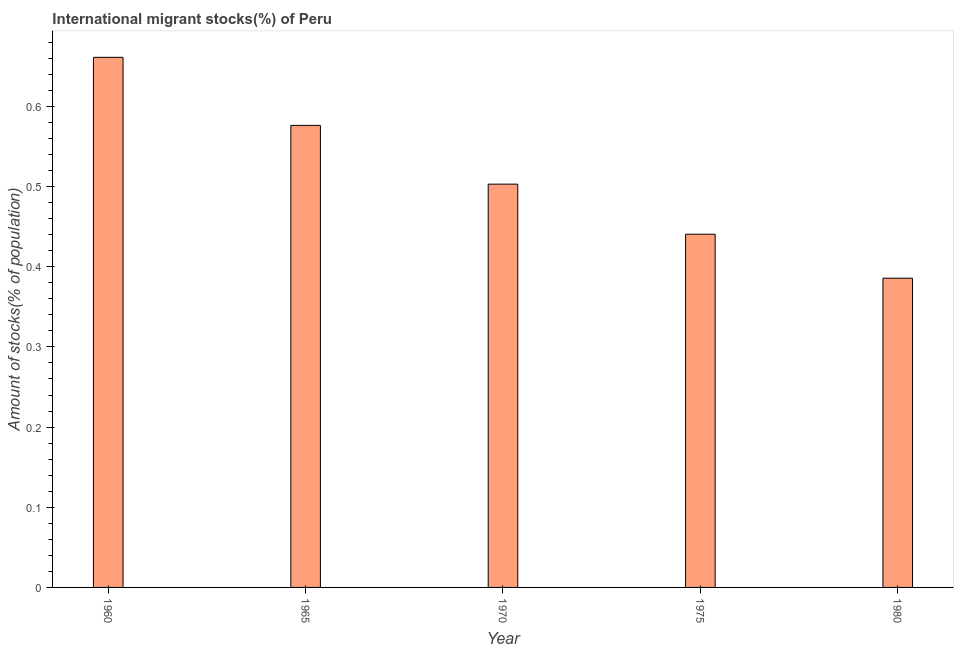Does the graph contain grids?
Your answer should be compact. No. What is the title of the graph?
Provide a short and direct response. International migrant stocks(%) of Peru. What is the label or title of the Y-axis?
Give a very brief answer. Amount of stocks(% of population). What is the number of international migrant stocks in 1965?
Your answer should be compact. 0.58. Across all years, what is the maximum number of international migrant stocks?
Make the answer very short. 0.66. Across all years, what is the minimum number of international migrant stocks?
Provide a short and direct response. 0.39. What is the sum of the number of international migrant stocks?
Your answer should be compact. 2.57. What is the difference between the number of international migrant stocks in 1975 and 1980?
Offer a terse response. 0.06. What is the average number of international migrant stocks per year?
Your answer should be very brief. 0.51. What is the median number of international migrant stocks?
Provide a short and direct response. 0.5. Do a majority of the years between 1965 and 1975 (inclusive) have number of international migrant stocks greater than 0.58 %?
Your answer should be compact. No. What is the ratio of the number of international migrant stocks in 1960 to that in 1970?
Provide a short and direct response. 1.31. What is the difference between the highest and the second highest number of international migrant stocks?
Your answer should be very brief. 0.09. Is the sum of the number of international migrant stocks in 1960 and 1980 greater than the maximum number of international migrant stocks across all years?
Give a very brief answer. Yes. What is the difference between the highest and the lowest number of international migrant stocks?
Your response must be concise. 0.28. In how many years, is the number of international migrant stocks greater than the average number of international migrant stocks taken over all years?
Your response must be concise. 2. Are all the bars in the graph horizontal?
Keep it short and to the point. No. What is the difference between two consecutive major ticks on the Y-axis?
Offer a very short reply. 0.1. Are the values on the major ticks of Y-axis written in scientific E-notation?
Provide a succinct answer. No. What is the Amount of stocks(% of population) of 1960?
Your response must be concise. 0.66. What is the Amount of stocks(% of population) of 1965?
Give a very brief answer. 0.58. What is the Amount of stocks(% of population) of 1970?
Offer a very short reply. 0.5. What is the Amount of stocks(% of population) of 1975?
Your response must be concise. 0.44. What is the Amount of stocks(% of population) in 1980?
Your answer should be very brief. 0.39. What is the difference between the Amount of stocks(% of population) in 1960 and 1965?
Your answer should be very brief. 0.08. What is the difference between the Amount of stocks(% of population) in 1960 and 1970?
Ensure brevity in your answer.  0.16. What is the difference between the Amount of stocks(% of population) in 1960 and 1975?
Your response must be concise. 0.22. What is the difference between the Amount of stocks(% of population) in 1960 and 1980?
Provide a succinct answer. 0.28. What is the difference between the Amount of stocks(% of population) in 1965 and 1970?
Make the answer very short. 0.07. What is the difference between the Amount of stocks(% of population) in 1965 and 1975?
Your answer should be very brief. 0.14. What is the difference between the Amount of stocks(% of population) in 1965 and 1980?
Provide a short and direct response. 0.19. What is the difference between the Amount of stocks(% of population) in 1970 and 1975?
Offer a terse response. 0.06. What is the difference between the Amount of stocks(% of population) in 1970 and 1980?
Your answer should be very brief. 0.12. What is the difference between the Amount of stocks(% of population) in 1975 and 1980?
Provide a succinct answer. 0.05. What is the ratio of the Amount of stocks(% of population) in 1960 to that in 1965?
Your answer should be very brief. 1.15. What is the ratio of the Amount of stocks(% of population) in 1960 to that in 1970?
Make the answer very short. 1.31. What is the ratio of the Amount of stocks(% of population) in 1960 to that in 1975?
Keep it short and to the point. 1.5. What is the ratio of the Amount of stocks(% of population) in 1960 to that in 1980?
Give a very brief answer. 1.71. What is the ratio of the Amount of stocks(% of population) in 1965 to that in 1970?
Offer a terse response. 1.15. What is the ratio of the Amount of stocks(% of population) in 1965 to that in 1975?
Your answer should be compact. 1.31. What is the ratio of the Amount of stocks(% of population) in 1965 to that in 1980?
Offer a terse response. 1.49. What is the ratio of the Amount of stocks(% of population) in 1970 to that in 1975?
Provide a succinct answer. 1.14. What is the ratio of the Amount of stocks(% of population) in 1970 to that in 1980?
Your answer should be compact. 1.3. What is the ratio of the Amount of stocks(% of population) in 1975 to that in 1980?
Keep it short and to the point. 1.14. 